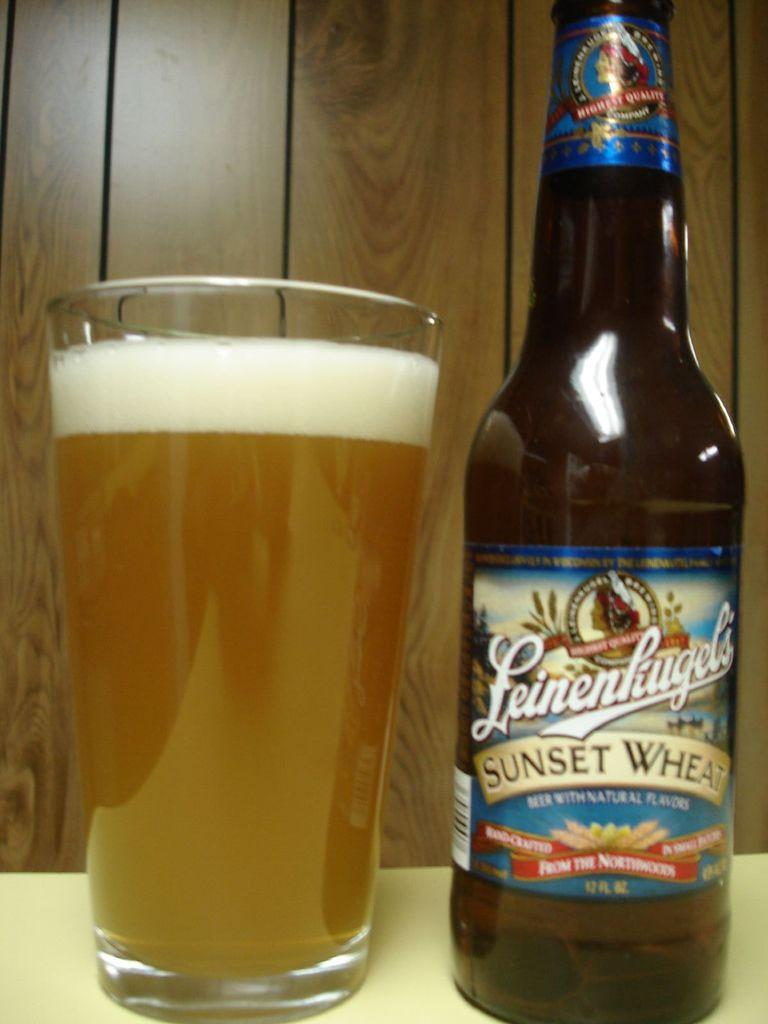<image>
Render a clear and concise summary of the photo. A leinenliugel's sunset wheat beer is on the table. 